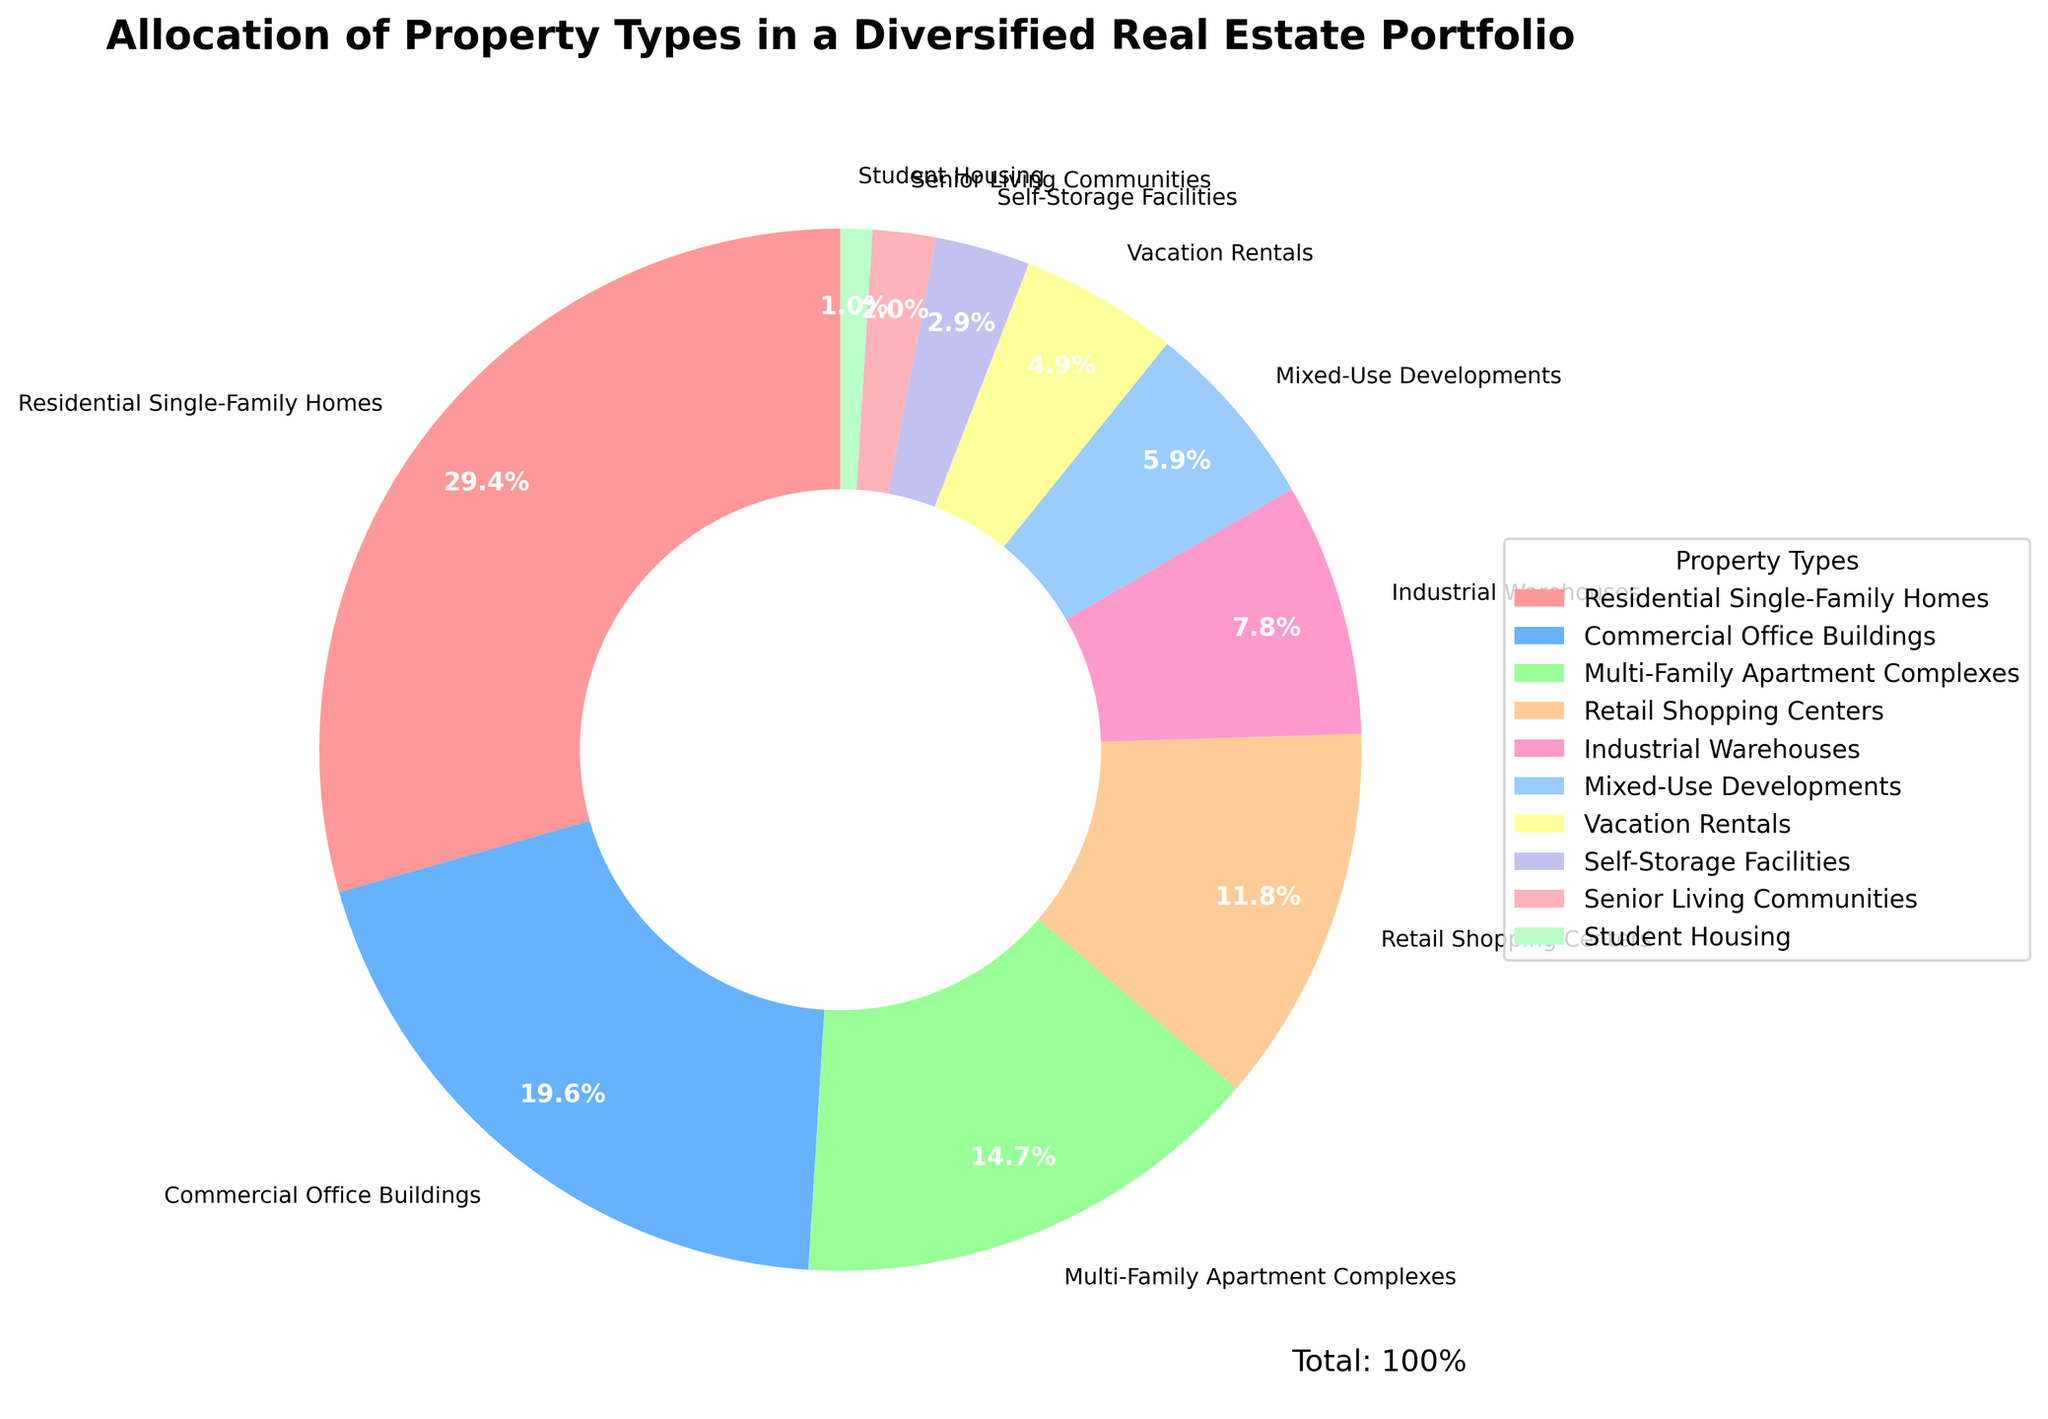what is the largest property type allocation in the portfolio? The property type with the highest percentage is Residential Single-Family Homes, which is clearly labeled on the pie chart as comprising 30% of the portfolio.
Answer: Residential Single-Family Homes Which property type has the smallest allocation? The smallest allocation in the pie chart is Student Housing, which is labeled at 1% of the portfolio.
Answer: Student Housing What is the combined percentage of Commercial Office Buildings and Retail Shopping Centers? The percentages for Commercial Office Buildings and Retail Shopping Centers are 20% and 12% respectively. Adding these together gives 20% + 12% = 32%.
Answer: 32% Is the allocation of Industrial Warehouses greater than that of Mixed-Use Developments? Industrial Warehouses have an allocation of 8%, while Mixed-Use Developments have an allocation of 6%, as shown in the pie chart. 8% > 6%, so yes, Industrial Warehouses have a greater allocation.
Answer: Yes How much greater is the percentage of Residential Single-Family Homes compared to Multi-Family Apartment Complexes? The pie chart shows Residential Single-Family Homes at 30% and Multi-Family Apartment Complexes at 15%. The difference is 30% - 15% = 15%.
Answer: 15% What is the total percentage allocation of the top three property types? The top three property types by allocation are Residential Single-Family Homes (30%), Commercial Office Buildings (20%), and Multi-Family Apartment Complexes (15%). Their total percentage is 30% + 20% + 15% = 65%.
Answer: 65% Does the percentage of Vacation Rentals exceed that of Self-Storage Facilities and Senior Living Communities combined? Vacation Rentals have an allocation of 5%, while Self-Storage Facilities and Senior Living Communities have 3% and 2% respectively. Combined, the latter two total 3% + 2% = 5%. Since 5% is not greater than 5%, the answer is no.
Answer: No If the percentage allocated to Retail Shopping Centers and Mixed-Use Developments were combined, would it surpass the allocation of Commercial Office Buildings? Retail Shopping Centers are allocated 12% and Mixed-Use Developments are allocated 6%. Together, they total 12% + 6% = 18%. Since 18% is less than the 20% allocated to Commercial Office Buildings, the combined percentage does not surpass it.
Answer: No 